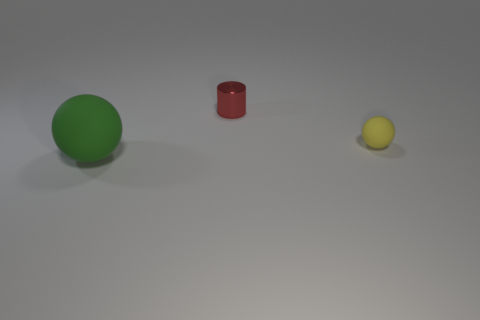How many other things are there of the same color as the small cylinder?
Provide a short and direct response. 0. Are there fewer small yellow rubber things behind the small red metal cylinder than big green rubber spheres?
Your answer should be very brief. Yes. What number of large yellow cylinders are there?
Your response must be concise. 0. How many tiny brown cubes are the same material as the green ball?
Offer a terse response. 0. How many objects are either tiny objects right of the red shiny cylinder or green things?
Ensure brevity in your answer.  2. Is the number of green matte things on the left side of the green thing less than the number of green matte spheres in front of the tiny yellow matte sphere?
Provide a short and direct response. Yes. Are there any small red objects in front of the large matte object?
Give a very brief answer. No. How many things are either matte objects that are in front of the yellow matte ball or things that are on the right side of the green matte sphere?
Give a very brief answer. 3. There is another tiny thing that is the same shape as the green rubber thing; what color is it?
Your answer should be compact. Yellow. What shape is the thing that is both left of the small yellow matte sphere and to the right of the large green rubber ball?
Provide a short and direct response. Cylinder. 